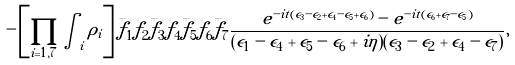<formula> <loc_0><loc_0><loc_500><loc_500>- \left [ \prod _ { i = 1 , 7 } \int _ { i } \rho _ { i } \right ] \bar { f } _ { 1 } f _ { 2 } \bar { f } _ { 3 } f _ { 4 } \bar { f } _ { 5 } f _ { 6 } \bar { f } _ { 7 } \frac { e ^ { - i t ( \epsilon _ { 3 } - \epsilon _ { 2 } + \epsilon _ { 4 } - \epsilon _ { 5 } + \epsilon _ { 6 } ) } - e ^ { - i t ( \epsilon _ { 6 } + \epsilon _ { 7 } - \epsilon _ { 5 } ) } } { ( \epsilon _ { 1 } - \epsilon _ { 4 } + \epsilon _ { 5 } - \epsilon _ { 6 } + i \eta ) ( \epsilon _ { 3 } - \epsilon _ { 2 } + \epsilon _ { 4 } - \epsilon _ { 7 } ) } ,</formula> 